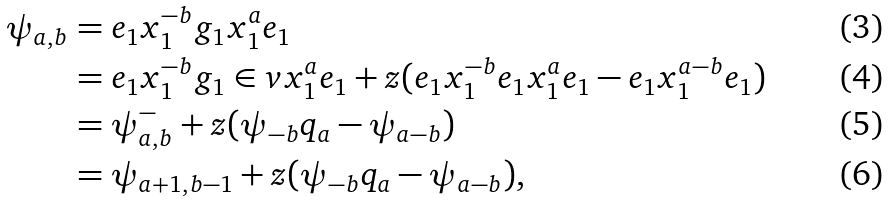Convert formula to latex. <formula><loc_0><loc_0><loc_500><loc_500>\psi _ { a , b } & = e _ { 1 } x _ { 1 } ^ { - b } g _ { 1 } x _ { 1 } ^ { a } e _ { 1 } \\ & = e _ { 1 } x _ { 1 } ^ { - b } g _ { 1 } \in v x _ { 1 } ^ { a } e _ { 1 } + z ( e _ { 1 } x _ { 1 } ^ { - b } e _ { 1 } x _ { 1 } ^ { a } e _ { 1 } - e _ { 1 } x _ { 1 } ^ { a - b } e _ { 1 } ) \\ & = \psi _ { a , b } ^ { - } + z ( \psi _ { - b } q _ { a } - \psi _ { a - b } ) \\ & = \psi _ { a + 1 , b - 1 } + z ( \psi _ { - b } q _ { a } - \psi _ { a - b } ) ,</formula> 